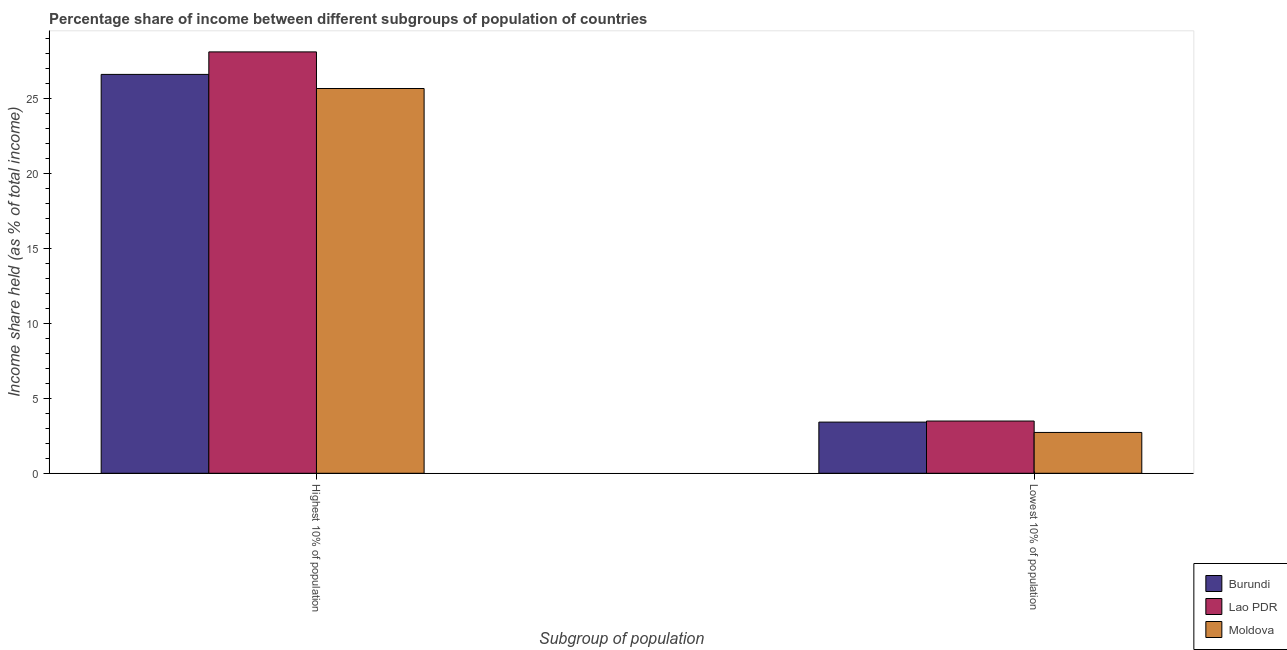How many bars are there on the 1st tick from the right?
Your response must be concise. 3. What is the label of the 2nd group of bars from the left?
Give a very brief answer. Lowest 10% of population. What is the income share held by lowest 10% of the population in Lao PDR?
Your answer should be compact. 3.48. Across all countries, what is the maximum income share held by lowest 10% of the population?
Offer a very short reply. 3.48. Across all countries, what is the minimum income share held by lowest 10% of the population?
Provide a short and direct response. 2.72. In which country was the income share held by highest 10% of the population maximum?
Ensure brevity in your answer.  Lao PDR. In which country was the income share held by highest 10% of the population minimum?
Provide a short and direct response. Moldova. What is the total income share held by lowest 10% of the population in the graph?
Keep it short and to the point. 9.61. What is the difference between the income share held by highest 10% of the population in Burundi and that in Moldova?
Provide a succinct answer. 0.94. What is the difference between the income share held by highest 10% of the population in Lao PDR and the income share held by lowest 10% of the population in Burundi?
Your answer should be very brief. 24.67. What is the average income share held by highest 10% of the population per country?
Keep it short and to the point. 26.77. What is the difference between the income share held by lowest 10% of the population and income share held by highest 10% of the population in Burundi?
Provide a short and direct response. -23.17. What is the ratio of the income share held by lowest 10% of the population in Lao PDR to that in Burundi?
Your answer should be compact. 1.02. Is the income share held by highest 10% of the population in Lao PDR less than that in Burundi?
Your response must be concise. No. In how many countries, is the income share held by lowest 10% of the population greater than the average income share held by lowest 10% of the population taken over all countries?
Ensure brevity in your answer.  2. What does the 2nd bar from the left in Highest 10% of population represents?
Your response must be concise. Lao PDR. What does the 1st bar from the right in Highest 10% of population represents?
Your response must be concise. Moldova. How many bars are there?
Keep it short and to the point. 6. What is the difference between two consecutive major ticks on the Y-axis?
Provide a short and direct response. 5. Does the graph contain any zero values?
Make the answer very short. No. What is the title of the graph?
Provide a succinct answer. Percentage share of income between different subgroups of population of countries. Does "Madagascar" appear as one of the legend labels in the graph?
Your answer should be very brief. No. What is the label or title of the X-axis?
Offer a terse response. Subgroup of population. What is the label or title of the Y-axis?
Your answer should be very brief. Income share held (as % of total income). What is the Income share held (as % of total income) in Burundi in Highest 10% of population?
Your answer should be very brief. 26.58. What is the Income share held (as % of total income) in Lao PDR in Highest 10% of population?
Keep it short and to the point. 28.08. What is the Income share held (as % of total income) of Moldova in Highest 10% of population?
Provide a succinct answer. 25.64. What is the Income share held (as % of total income) of Burundi in Lowest 10% of population?
Your response must be concise. 3.41. What is the Income share held (as % of total income) in Lao PDR in Lowest 10% of population?
Your answer should be very brief. 3.48. What is the Income share held (as % of total income) of Moldova in Lowest 10% of population?
Your answer should be very brief. 2.72. Across all Subgroup of population, what is the maximum Income share held (as % of total income) of Burundi?
Provide a succinct answer. 26.58. Across all Subgroup of population, what is the maximum Income share held (as % of total income) in Lao PDR?
Ensure brevity in your answer.  28.08. Across all Subgroup of population, what is the maximum Income share held (as % of total income) in Moldova?
Your answer should be compact. 25.64. Across all Subgroup of population, what is the minimum Income share held (as % of total income) in Burundi?
Keep it short and to the point. 3.41. Across all Subgroup of population, what is the minimum Income share held (as % of total income) of Lao PDR?
Offer a terse response. 3.48. Across all Subgroup of population, what is the minimum Income share held (as % of total income) of Moldova?
Your answer should be very brief. 2.72. What is the total Income share held (as % of total income) in Burundi in the graph?
Your answer should be very brief. 29.99. What is the total Income share held (as % of total income) of Lao PDR in the graph?
Make the answer very short. 31.56. What is the total Income share held (as % of total income) of Moldova in the graph?
Your response must be concise. 28.36. What is the difference between the Income share held (as % of total income) in Burundi in Highest 10% of population and that in Lowest 10% of population?
Your answer should be very brief. 23.17. What is the difference between the Income share held (as % of total income) in Lao PDR in Highest 10% of population and that in Lowest 10% of population?
Ensure brevity in your answer.  24.6. What is the difference between the Income share held (as % of total income) of Moldova in Highest 10% of population and that in Lowest 10% of population?
Keep it short and to the point. 22.92. What is the difference between the Income share held (as % of total income) of Burundi in Highest 10% of population and the Income share held (as % of total income) of Lao PDR in Lowest 10% of population?
Offer a very short reply. 23.1. What is the difference between the Income share held (as % of total income) in Burundi in Highest 10% of population and the Income share held (as % of total income) in Moldova in Lowest 10% of population?
Keep it short and to the point. 23.86. What is the difference between the Income share held (as % of total income) in Lao PDR in Highest 10% of population and the Income share held (as % of total income) in Moldova in Lowest 10% of population?
Provide a succinct answer. 25.36. What is the average Income share held (as % of total income) in Burundi per Subgroup of population?
Keep it short and to the point. 14.99. What is the average Income share held (as % of total income) of Lao PDR per Subgroup of population?
Your response must be concise. 15.78. What is the average Income share held (as % of total income) in Moldova per Subgroup of population?
Your answer should be very brief. 14.18. What is the difference between the Income share held (as % of total income) of Burundi and Income share held (as % of total income) of Lao PDR in Highest 10% of population?
Your answer should be compact. -1.5. What is the difference between the Income share held (as % of total income) of Lao PDR and Income share held (as % of total income) of Moldova in Highest 10% of population?
Give a very brief answer. 2.44. What is the difference between the Income share held (as % of total income) of Burundi and Income share held (as % of total income) of Lao PDR in Lowest 10% of population?
Provide a short and direct response. -0.07. What is the difference between the Income share held (as % of total income) in Burundi and Income share held (as % of total income) in Moldova in Lowest 10% of population?
Keep it short and to the point. 0.69. What is the difference between the Income share held (as % of total income) of Lao PDR and Income share held (as % of total income) of Moldova in Lowest 10% of population?
Your answer should be compact. 0.76. What is the ratio of the Income share held (as % of total income) in Burundi in Highest 10% of population to that in Lowest 10% of population?
Offer a very short reply. 7.79. What is the ratio of the Income share held (as % of total income) of Lao PDR in Highest 10% of population to that in Lowest 10% of population?
Keep it short and to the point. 8.07. What is the ratio of the Income share held (as % of total income) of Moldova in Highest 10% of population to that in Lowest 10% of population?
Your response must be concise. 9.43. What is the difference between the highest and the second highest Income share held (as % of total income) in Burundi?
Offer a very short reply. 23.17. What is the difference between the highest and the second highest Income share held (as % of total income) of Lao PDR?
Keep it short and to the point. 24.6. What is the difference between the highest and the second highest Income share held (as % of total income) in Moldova?
Ensure brevity in your answer.  22.92. What is the difference between the highest and the lowest Income share held (as % of total income) of Burundi?
Provide a short and direct response. 23.17. What is the difference between the highest and the lowest Income share held (as % of total income) in Lao PDR?
Give a very brief answer. 24.6. What is the difference between the highest and the lowest Income share held (as % of total income) of Moldova?
Provide a succinct answer. 22.92. 